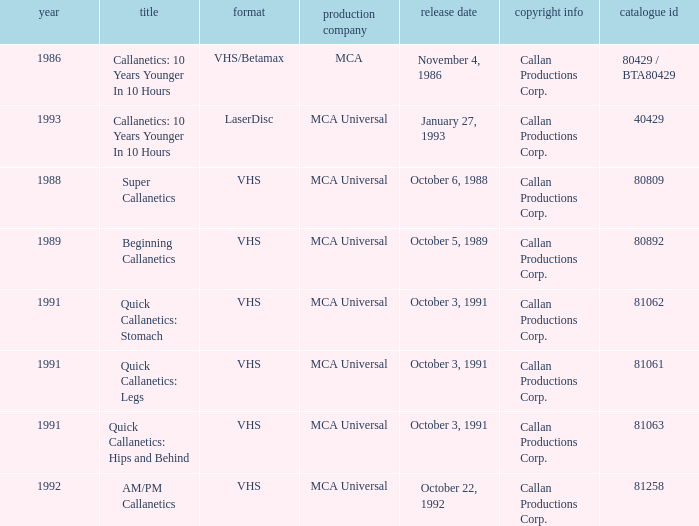Name the format for super callanetics VHS. 